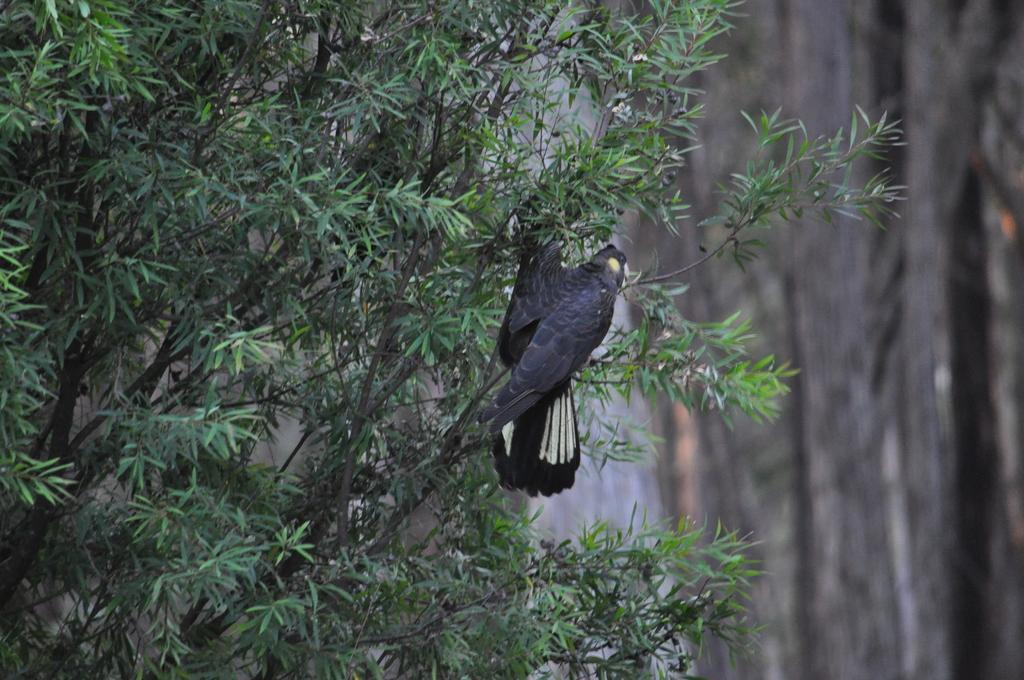What type of plant can be seen in the image? There is a tree in the image. Can you describe the bird in the image? A bird is laying on a branch of the tree. Where is the basin located in the image? There is no basin present in the image. What type of rifle can be seen in the image? There is no rifle present in the image. 